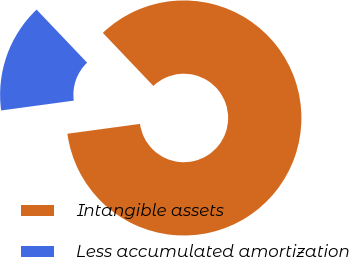Convert chart. <chart><loc_0><loc_0><loc_500><loc_500><pie_chart><fcel>Intangible assets<fcel>Less accumulated amortization<nl><fcel>84.97%<fcel>15.03%<nl></chart> 